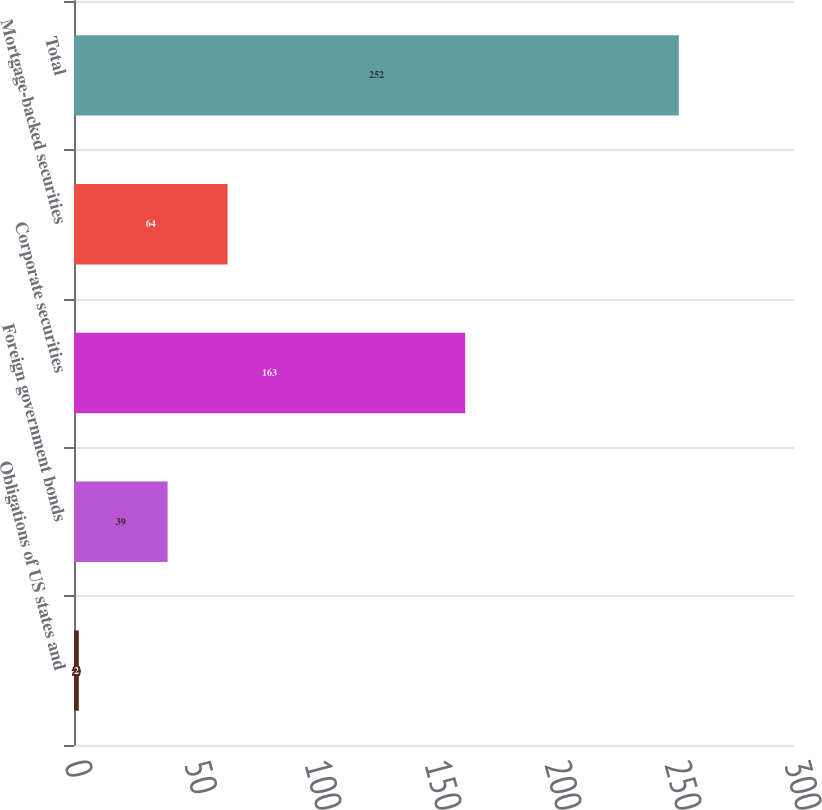<chart> <loc_0><loc_0><loc_500><loc_500><bar_chart><fcel>Obligations of US states and<fcel>Foreign government bonds<fcel>Corporate securities<fcel>Mortgage-backed securities<fcel>Total<nl><fcel>2<fcel>39<fcel>163<fcel>64<fcel>252<nl></chart> 